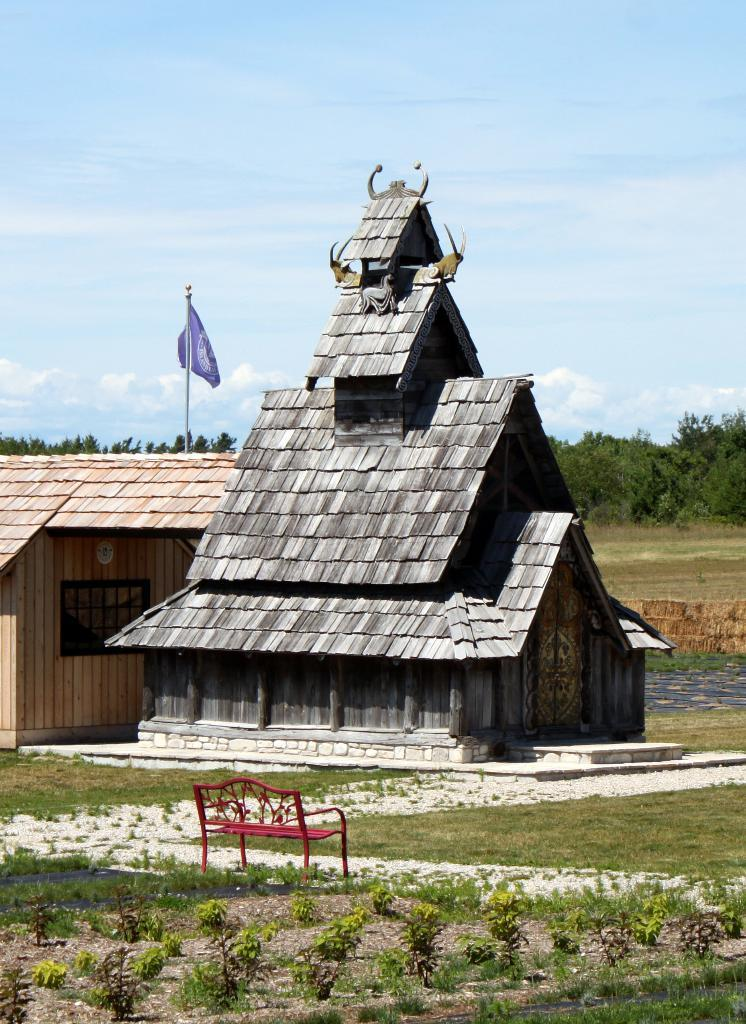What type of structures can be seen in the image? There are houses in the image. Are there any specific features on one of the houses? Yes, there is a flag on one of the houses. What type of seating is available in the image? There is a metal bench in the image. What type of vegetation is present in the image? Plants and trees are present in the image. What is the ground covered with in the image? Grass is visible on the ground. What is the condition of the sky in the image? The sky is blue and cloudy. What type of toothbrush is the son using in the image? There is no son or toothbrush present in the image. 